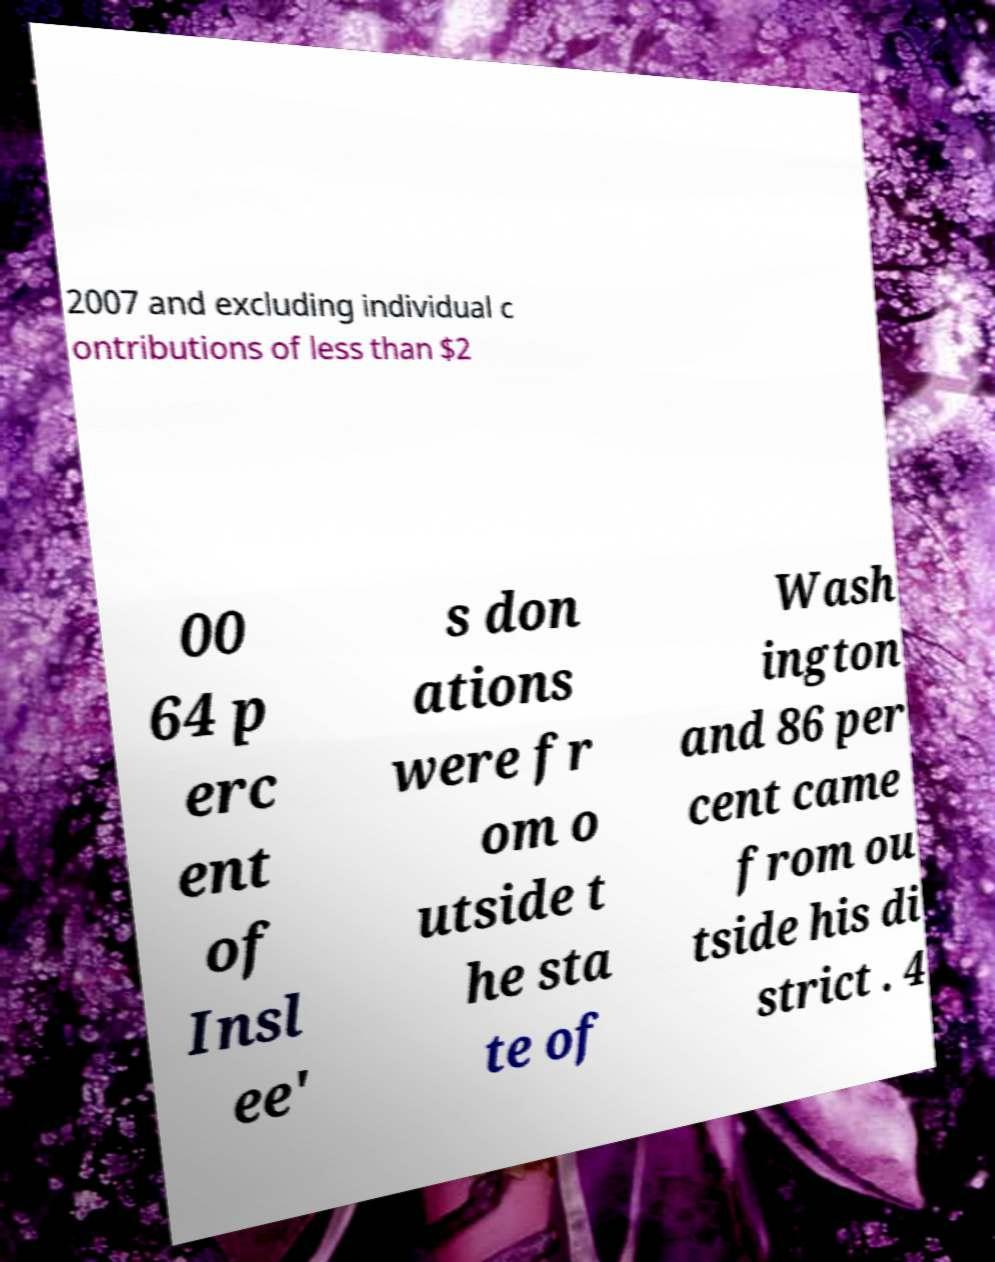What messages or text are displayed in this image? I need them in a readable, typed format. 2007 and excluding individual c ontributions of less than $2 00 64 p erc ent of Insl ee' s don ations were fr om o utside t he sta te of Wash ington and 86 per cent came from ou tside his di strict . 4 